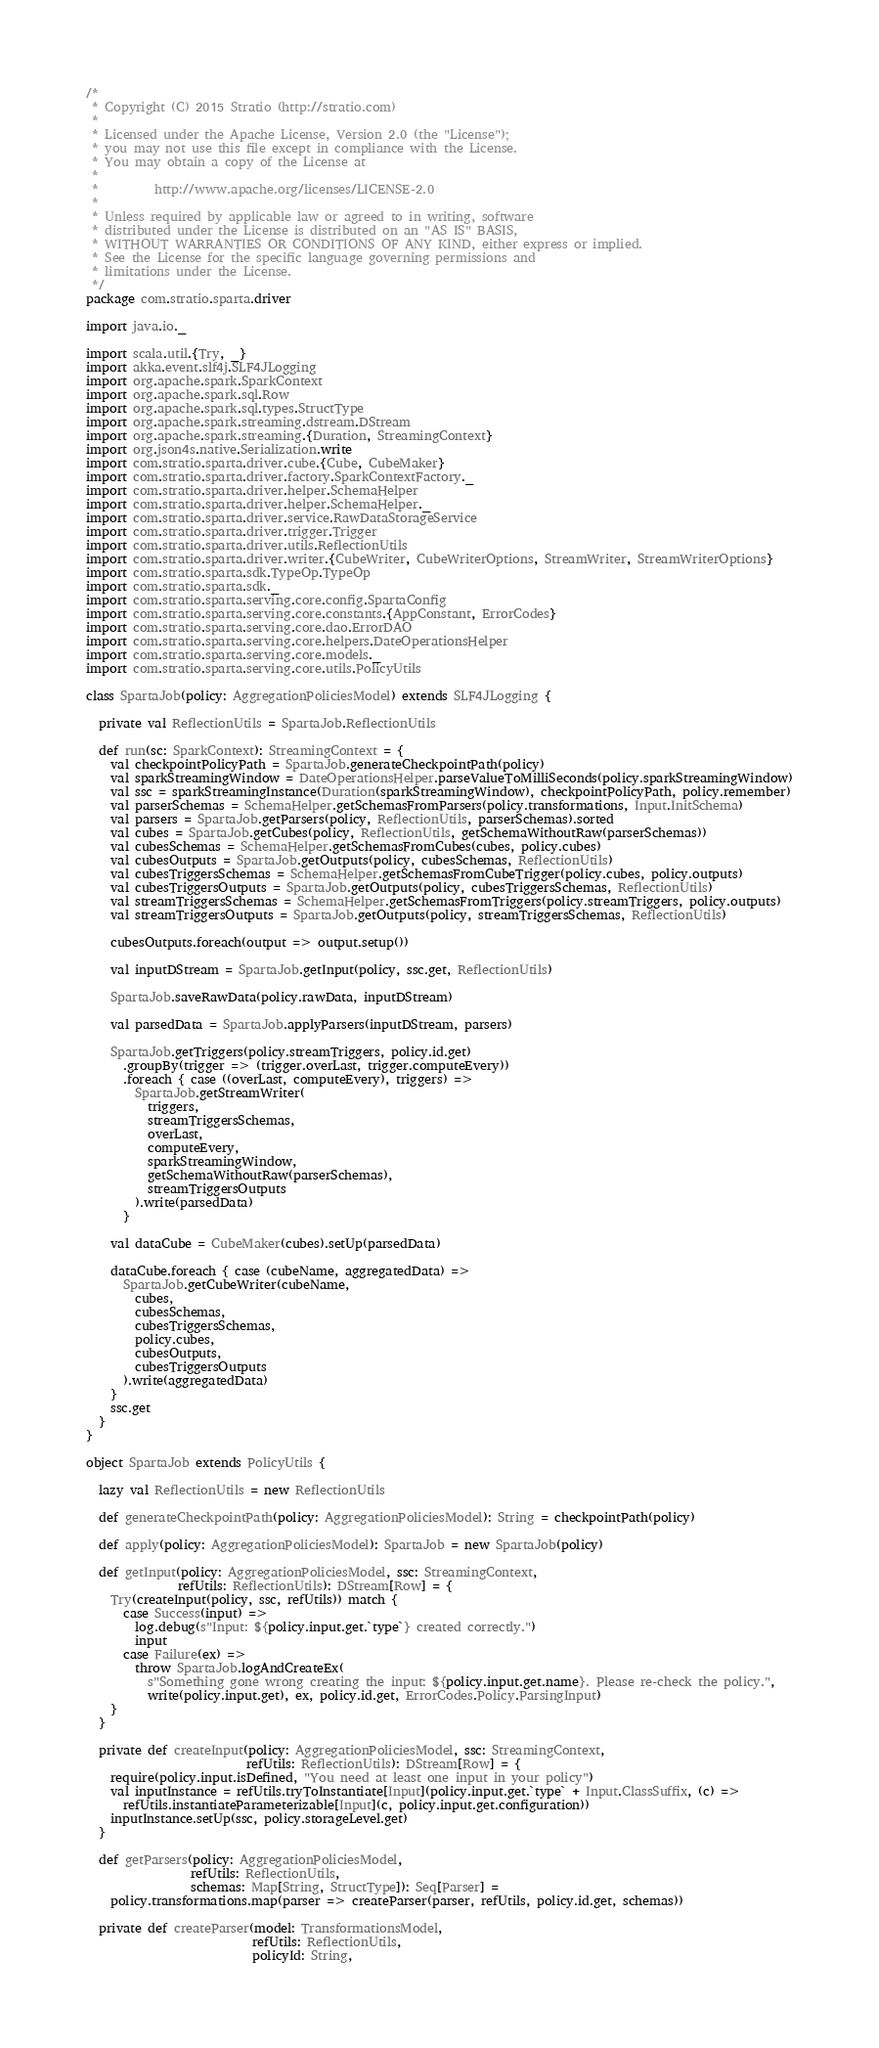<code> <loc_0><loc_0><loc_500><loc_500><_Scala_>/*
 * Copyright (C) 2015 Stratio (http://stratio.com)
 *
 * Licensed under the Apache License, Version 2.0 (the "License");
 * you may not use this file except in compliance with the License.
 * You may obtain a copy of the License at
 *
 *         http://www.apache.org/licenses/LICENSE-2.0
 *
 * Unless required by applicable law or agreed to in writing, software
 * distributed under the License is distributed on an "AS IS" BASIS,
 * WITHOUT WARRANTIES OR CONDITIONS OF ANY KIND, either express or implied.
 * See the License for the specific language governing permissions and
 * limitations under the License.
 */
package com.stratio.sparta.driver

import java.io._

import scala.util.{Try, _}
import akka.event.slf4j.SLF4JLogging
import org.apache.spark.SparkContext
import org.apache.spark.sql.Row
import org.apache.spark.sql.types.StructType
import org.apache.spark.streaming.dstream.DStream
import org.apache.spark.streaming.{Duration, StreamingContext}
import org.json4s.native.Serialization.write
import com.stratio.sparta.driver.cube.{Cube, CubeMaker}
import com.stratio.sparta.driver.factory.SparkContextFactory._
import com.stratio.sparta.driver.helper.SchemaHelper
import com.stratio.sparta.driver.helper.SchemaHelper._
import com.stratio.sparta.driver.service.RawDataStorageService
import com.stratio.sparta.driver.trigger.Trigger
import com.stratio.sparta.driver.utils.ReflectionUtils
import com.stratio.sparta.driver.writer.{CubeWriter, CubeWriterOptions, StreamWriter, StreamWriterOptions}
import com.stratio.sparta.sdk.TypeOp.TypeOp
import com.stratio.sparta.sdk._
import com.stratio.sparta.serving.core.config.SpartaConfig
import com.stratio.sparta.serving.core.constants.{AppConstant, ErrorCodes}
import com.stratio.sparta.serving.core.dao.ErrorDAO
import com.stratio.sparta.serving.core.helpers.DateOperationsHelper
import com.stratio.sparta.serving.core.models._
import com.stratio.sparta.serving.core.utils.PolicyUtils

class SpartaJob(policy: AggregationPoliciesModel) extends SLF4JLogging {

  private val ReflectionUtils = SpartaJob.ReflectionUtils

  def run(sc: SparkContext): StreamingContext = {
    val checkpointPolicyPath = SpartaJob.generateCheckpointPath(policy)
    val sparkStreamingWindow = DateOperationsHelper.parseValueToMilliSeconds(policy.sparkStreamingWindow)
    val ssc = sparkStreamingInstance(Duration(sparkStreamingWindow), checkpointPolicyPath, policy.remember)
    val parserSchemas = SchemaHelper.getSchemasFromParsers(policy.transformations, Input.InitSchema)
    val parsers = SpartaJob.getParsers(policy, ReflectionUtils, parserSchemas).sorted
    val cubes = SpartaJob.getCubes(policy, ReflectionUtils, getSchemaWithoutRaw(parserSchemas))
    val cubesSchemas = SchemaHelper.getSchemasFromCubes(cubes, policy.cubes)
    val cubesOutputs = SpartaJob.getOutputs(policy, cubesSchemas, ReflectionUtils)
    val cubesTriggersSchemas = SchemaHelper.getSchemasFromCubeTrigger(policy.cubes, policy.outputs)
    val cubesTriggersOutputs = SpartaJob.getOutputs(policy, cubesTriggersSchemas, ReflectionUtils)
    val streamTriggersSchemas = SchemaHelper.getSchemasFromTriggers(policy.streamTriggers, policy.outputs)
    val streamTriggersOutputs = SpartaJob.getOutputs(policy, streamTriggersSchemas, ReflectionUtils)

    cubesOutputs.foreach(output => output.setup())

    val inputDStream = SpartaJob.getInput(policy, ssc.get, ReflectionUtils)

    SpartaJob.saveRawData(policy.rawData, inputDStream)

    val parsedData = SpartaJob.applyParsers(inputDStream, parsers)

    SpartaJob.getTriggers(policy.streamTriggers, policy.id.get)
      .groupBy(trigger => (trigger.overLast, trigger.computeEvery))
      .foreach { case ((overLast, computeEvery), triggers) =>
        SpartaJob.getStreamWriter(
          triggers,
          streamTriggersSchemas,
          overLast,
          computeEvery,
          sparkStreamingWindow,
          getSchemaWithoutRaw(parserSchemas),
          streamTriggersOutputs
        ).write(parsedData)
      }

    val dataCube = CubeMaker(cubes).setUp(parsedData)

    dataCube.foreach { case (cubeName, aggregatedData) =>
      SpartaJob.getCubeWriter(cubeName,
        cubes,
        cubesSchemas,
        cubesTriggersSchemas,
        policy.cubes,
        cubesOutputs,
        cubesTriggersOutputs
      ).write(aggregatedData)
    }
    ssc.get
  }
}

object SpartaJob extends PolicyUtils {

  lazy val ReflectionUtils = new ReflectionUtils

  def generateCheckpointPath(policy: AggregationPoliciesModel): String = checkpointPath(policy)

  def apply(policy: AggregationPoliciesModel): SpartaJob = new SpartaJob(policy)

  def getInput(policy: AggregationPoliciesModel, ssc: StreamingContext,
               refUtils: ReflectionUtils): DStream[Row] = {
    Try(createInput(policy, ssc, refUtils)) match {
      case Success(input) =>
        log.debug(s"Input: ${policy.input.get.`type`} created correctly.")
        input
      case Failure(ex) =>
        throw SpartaJob.logAndCreateEx(
          s"Something gone wrong creating the input: ${policy.input.get.name}. Please re-check the policy.",
          write(policy.input.get), ex, policy.id.get, ErrorCodes.Policy.ParsingInput)
    }
  }

  private def createInput(policy: AggregationPoliciesModel, ssc: StreamingContext,
                          refUtils: ReflectionUtils): DStream[Row] = {
    require(policy.input.isDefined, "You need at least one input in your policy")
    val inputInstance = refUtils.tryToInstantiate[Input](policy.input.get.`type` + Input.ClassSuffix, (c) =>
      refUtils.instantiateParameterizable[Input](c, policy.input.get.configuration))
    inputInstance.setUp(ssc, policy.storageLevel.get)
  }

  def getParsers(policy: AggregationPoliciesModel,
                 refUtils: ReflectionUtils,
                 schemas: Map[String, StructType]): Seq[Parser] =
    policy.transformations.map(parser => createParser(parser, refUtils, policy.id.get, schemas))

  private def createParser(model: TransformationsModel,
                           refUtils: ReflectionUtils,
                           policyId: String,</code> 